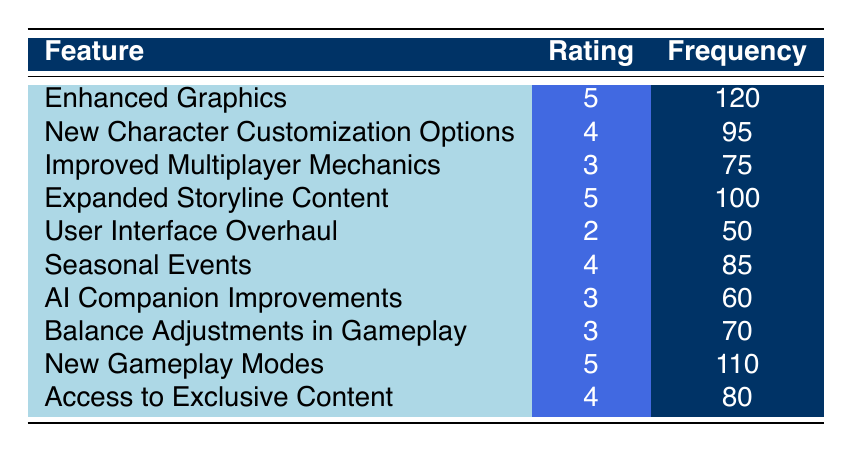What feature received the highest frequency of ratings? The highest frequency in the table can be identified by comparing the "Frequency" column values. "Enhanced Graphics" has a frequency of 120, which is the highest among all features listed.
Answer: Enhanced Graphics What is the total frequency of feedback for features rated 4? To find the total frequency for features rated 4, we sum the frequencies of those features: New Character Customization Options (95) + Seasonal Events (85) + Access to Exclusive Content (80) = 360.
Answer: 360 Is the rating for "User Interface Overhaul" greater than 3? By checking the "Rating" column for "User Interface Overhaul," we see it has a rating of 2, which is not greater than 3. Thus, the statement is false.
Answer: No How many features have a rating of 5? We can count the features with a rating of 5 by checking the "Rating" column. The features with this rating are "Enhanced Graphics," "Expanded Storyline Content," and "New Gameplay Modes," amounting to 3 features.
Answer: 3 What is the average rating for all the features? To compute the average rating, we sum all the ratings: (5 + 4 + 3 + 5 + 2 + 4 + 3 + 3 + 5 + 4) = 38. Then, divide by the number of features, which is 10, giving us an average of 38/10 = 3.8.
Answer: 3.8 Which feature rated 2 has the lowest frequency? There is only one feature with a rating of 2, which is "User Interface Overhaul" with a frequency of 50. Thus, this feature has the lowest frequency since it's the only one with that rating.
Answer: User Interface Overhaul Are there more features rated 3 or features rated 4? By checking the "Rating" column, we see there are 4 features rated 3 (Improved Multiplayer Mechanics, AI Companion Improvements, Balance Adjustments in Gameplay) and 4 features rated 4 (New Character Customization Options, Seasonal Events, Access to Exclusive Content). Since there is a tie, both ratings are equal in terms of the number of features.
Answer: Equal What feature has a frequency closest to 70? By reviewing the "Frequency" column, "Balance Adjustments in Gameplay" has a frequency of 70, which matches the criteria exactly, while "AI Companion Improvements" has a frequency of 60, which is further away.
Answer: Balance Adjustments in Gameplay If we remove the ratings of all features rated 2, what would be the total frequency? The only feature rated 2 is "User Interface Overhaul" with a frequency of 50. So, we sum the frequencies of all other features: (120 + 95 + 75 + 100 + 85 + 60 + 70 + 110 + 80) = 915.
Answer: 915 